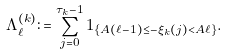Convert formula to latex. <formula><loc_0><loc_0><loc_500><loc_500>\Lambda _ { \ell } ^ { ( k ) } \colon = \sum _ { j = 0 } ^ { \tau _ { k } - 1 } 1 _ { \{ A ( \ell - 1 ) \leq - \xi _ { k } ( j ) < A \ell \} } .</formula> 